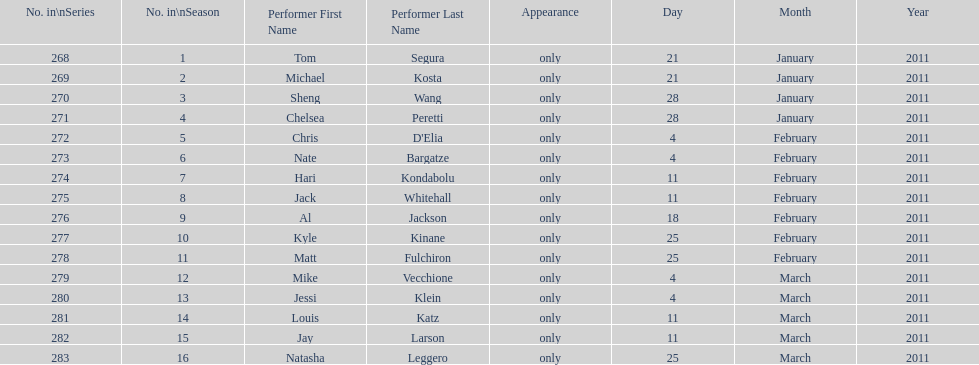How many comedians made their only appearance on comedy central presents in season 15? 16. 